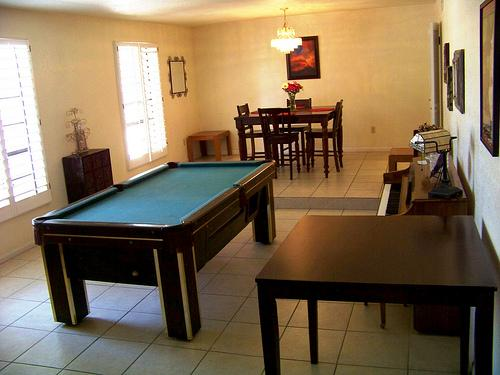What is the main type of furniture seen throughout the room? The main type of furniture in the room is tables, including a dinner table, a pool table, and a brown wood piano. Please provide a list of all furniture pieces present in the room, based on their descriptions provided. Dinner table, pool table, brown wood piano, window with blinds, square dining room table, chairs, square brown wood table, short brown wood table, and wood drawers with sculpture. Mention any objects related to art or decoration in the image. Art and decorative objects include a red painting in a wood frame, photographs on the wall, a sculpture on wood drawers, a colorful picture on the wall, and a vase of colorful flowers. Describe the floor of the room based on its attributes provided in the information. The floor of the room has tiles, which make up a clean and polished surface that supports the various pieces of furniture in the room. Which objects in the image have a significant interaction? The dining room table with four chairs and red place mats has a significant interaction, as they are all part of a setting for a meal. How many tables are in the image, and can you briefly describe their appearance and function? There are multiple tables in the image: a dinner table with red place mats, a square dining room table with four chairs, a dark wood pool table with green felt, and a brown wood piano as a smaller table-like structure. Please provide a brief description of the prominent objects in the image. The image features a dinner table, a wooden pool table with green felt, a brown wood piano, a window with blinds, a painting in a wood frame, photographs on the wall, and a light hanging from the ceiling. Discuss the overall atmosphere and feel of the room. The room has a cozy and warm atmosphere, with dark wood furniture, comfortable objects, and artistic decorations, creating an inviting and elegant space. What objects in the image have a connection with lights? A light hanging from the ceiling, an older lamp on top of the piano, and a small white lamp have a connection with lights in the image. Can you estimate the number of chairs in the image? There appear to be at least four chairs in the image, surrounding the square dining room table. Find the blue umbrella hanging on the wall and describe its pattern. There is no mention of a blue umbrella or any umbrella in the given image information. This instruction is misleading because it refers to a non-existent object and asks for a specific detail about it, further confusing the person trying to find it in the image. Is the dining table adorned with a white lace tablecloth? There is no mention of a tablecloth, let alone a white lace one, in the provided image information. This instruction is misleading because it asks a yes or no question about a non-existent object, potentially leading someone to think they've missed something in the image. Did you notice the cat sitting on top of the piano? Is it a male or a female? There is no mention of a cat in the provided image information. This instruction is misleading because it introduces the presence of an animal that doesn't exist in the image and additionally asks unrelated questions about the nonexistent animal's gender. Observe the potted plant near the window. What kind of plant is it? There is no mention of a potted plant in the given image information. This instruction is misleading because it introduces the presence of a non-existent object near an existing object (the window), potentially causing confusion for the person trying to find it in the image. Count the number of unopened wine bottles on the shelves around the room. There is no mention of wine bottles or shelves in the given image information. This instruction is misleading because it implies that there are wine bottles and shelves in the room, which are not present, thus causing confusion for the person trying to find them in the image. Identify the famous painting in the red frame on the left side of the room. Who is the artist? Although there is a red painting in a wood frame mentioned in the image information, there's no indication that it's famous or that it's on the left side of the room. This instruction is misleading as it gives incorrect details about an existing object and asks for information (the artist) that is not provided. 